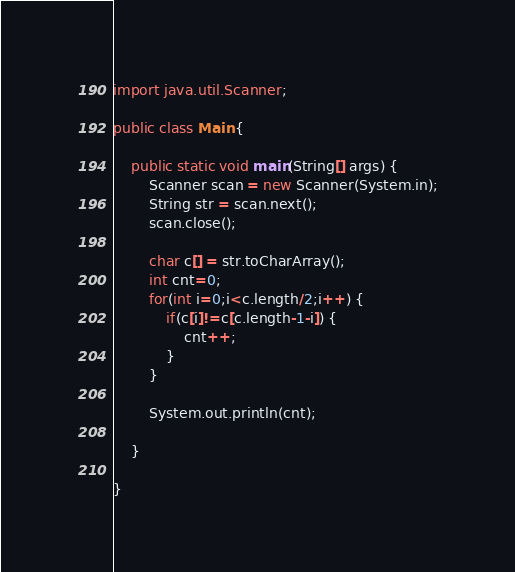<code> <loc_0><loc_0><loc_500><loc_500><_Java_>import java.util.Scanner;

public class Main {

	public static void main(String[] args) {
		Scanner scan = new Scanner(System.in);
		String str = scan.next();
		scan.close();

		char c[] = str.toCharArray();
		int cnt=0;
		for(int i=0;i<c.length/2;i++) {
			if(c[i]!=c[c.length-1-i]) {
				cnt++;
			}
		}

		System.out.println(cnt);

	}

}</code> 